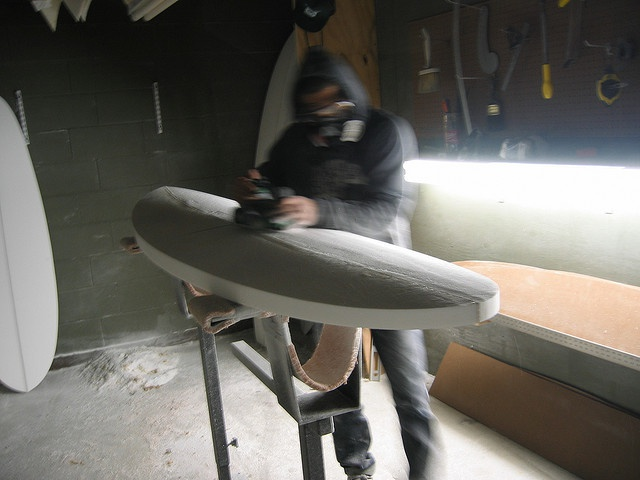Describe the objects in this image and their specific colors. I can see people in black, gray, darkgray, and lightgray tones, surfboard in black, gray, darkgray, and lightgray tones, and surfboard in black, darkgray, lightgray, gray, and darkgreen tones in this image. 